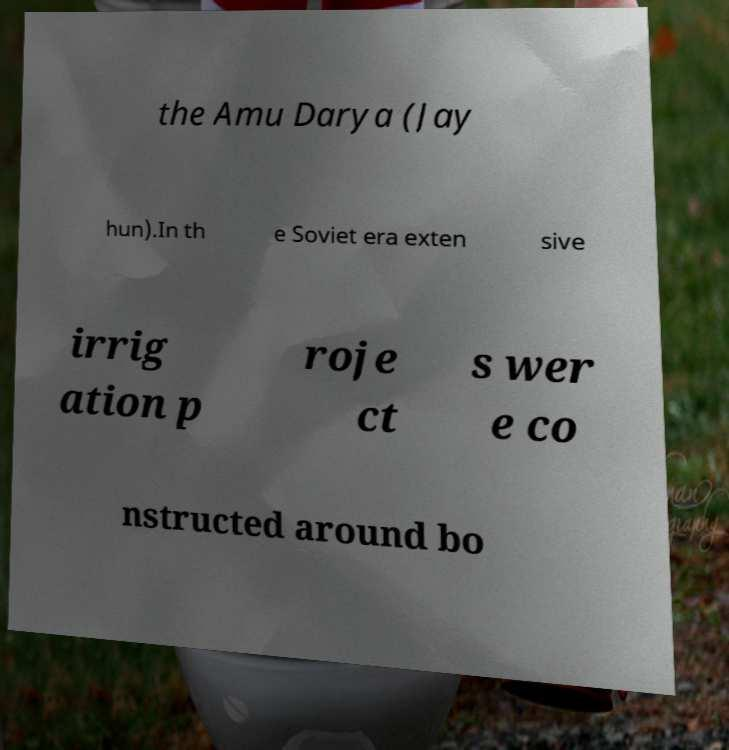Can you accurately transcribe the text from the provided image for me? the Amu Darya (Jay hun).In th e Soviet era exten sive irrig ation p roje ct s wer e co nstructed around bo 